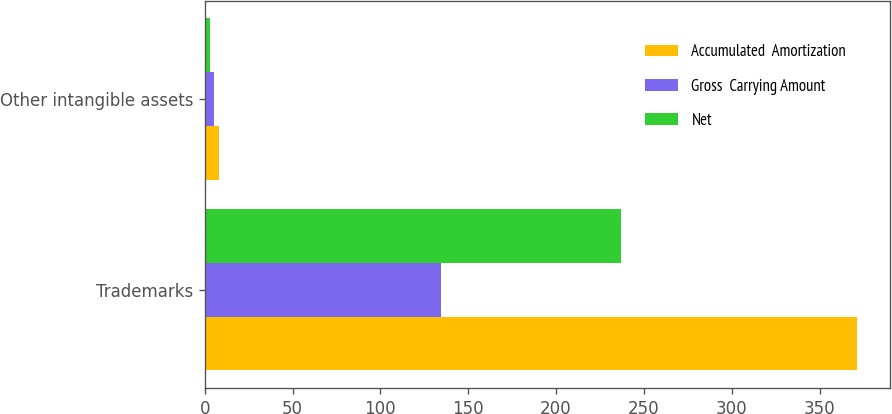Convert chart to OTSL. <chart><loc_0><loc_0><loc_500><loc_500><stacked_bar_chart><ecel><fcel>Trademarks<fcel>Other intangible assets<nl><fcel>Accumulated  Amortization<fcel>371.3<fcel>8.3<nl><fcel>Gross  Carrying Amount<fcel>134.4<fcel>5.1<nl><fcel>Net<fcel>236.9<fcel>3.2<nl></chart> 